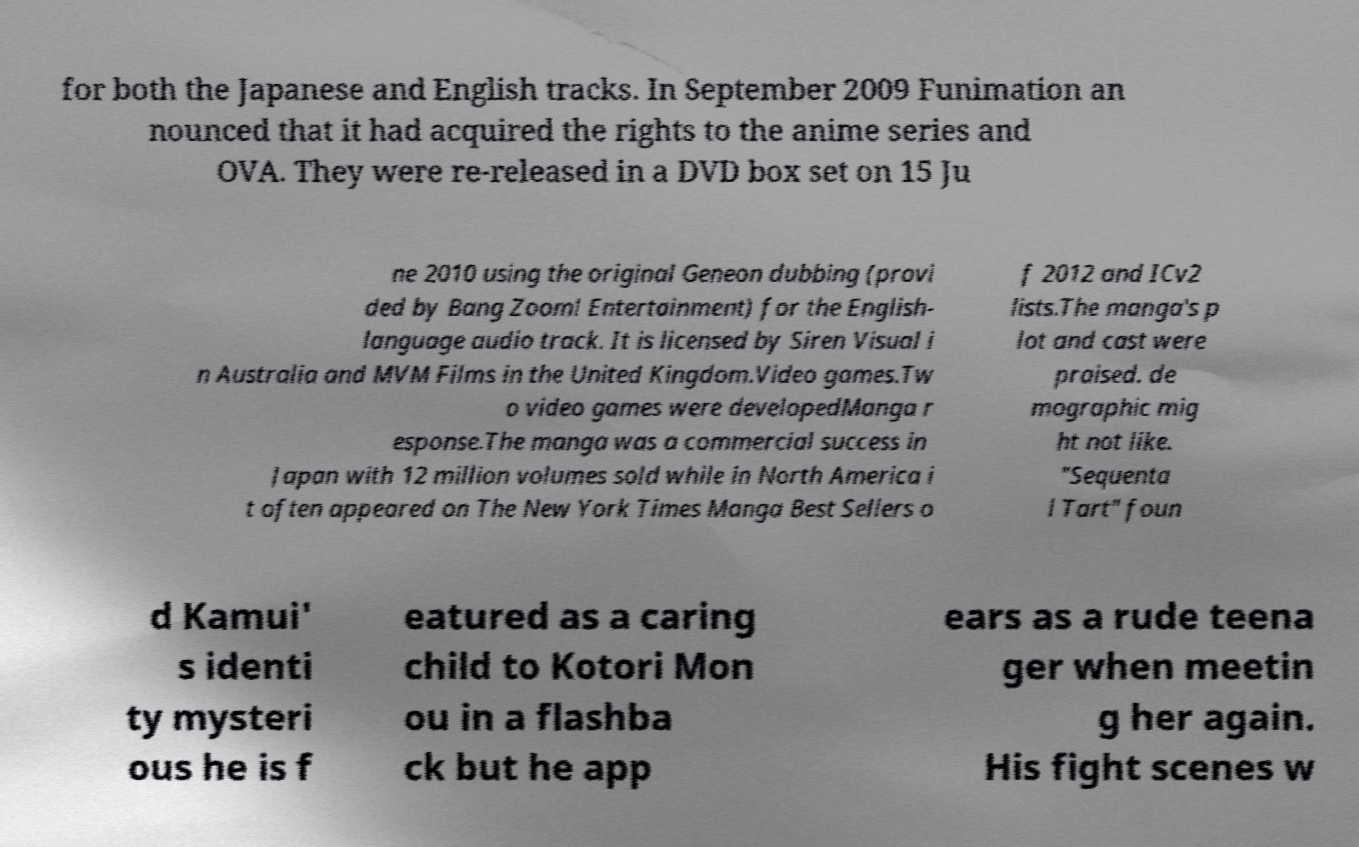Can you read and provide the text displayed in the image?This photo seems to have some interesting text. Can you extract and type it out for me? for both the Japanese and English tracks. In September 2009 Funimation an nounced that it had acquired the rights to the anime series and OVA. They were re-released in a DVD box set on 15 Ju ne 2010 using the original Geneon dubbing (provi ded by Bang Zoom! Entertainment) for the English- language audio track. It is licensed by Siren Visual i n Australia and MVM Films in the United Kingdom.Video games.Tw o video games were developedManga r esponse.The manga was a commercial success in Japan with 12 million volumes sold while in North America i t often appeared on The New York Times Manga Best Sellers o f 2012 and ICv2 lists.The manga's p lot and cast were praised. de mographic mig ht not like. "Sequenta l Tart" foun d Kamui' s identi ty mysteri ous he is f eatured as a caring child to Kotori Mon ou in a flashba ck but he app ears as a rude teena ger when meetin g her again. His fight scenes w 